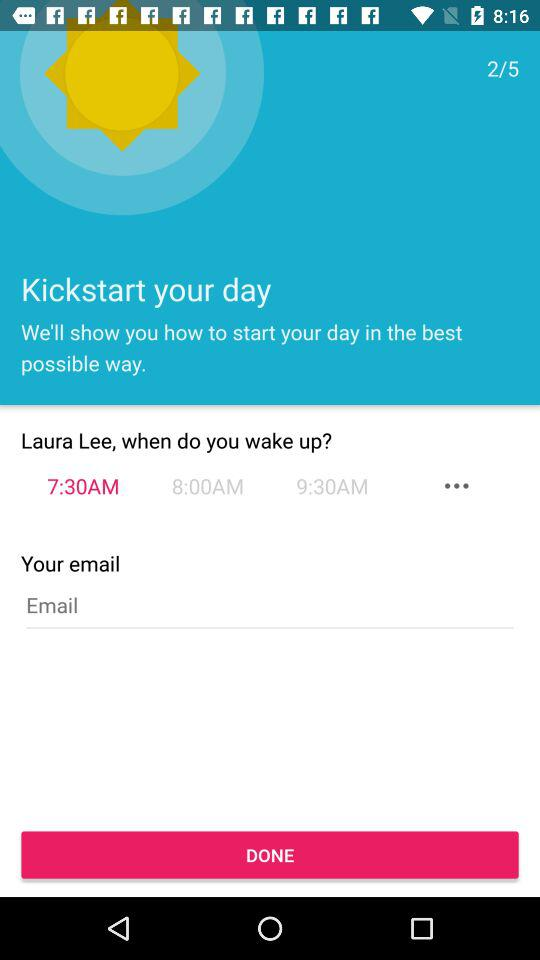How many hours are there between the latest and earliest wake up times?
Answer the question using a single word or phrase. 2 